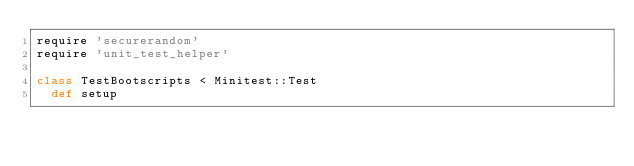Convert code to text. <code><loc_0><loc_0><loc_500><loc_500><_Ruby_>require 'securerandom'
require 'unit_test_helper'

class TestBootscripts < Minitest::Test
  def setup</code> 